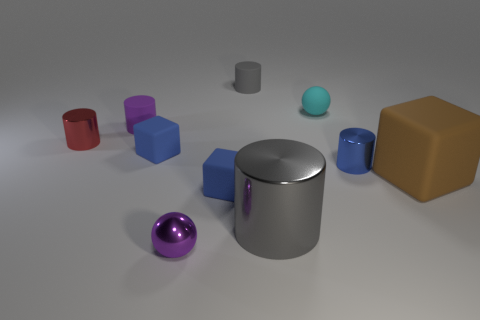Is there any other thing that has the same size as the matte sphere?
Offer a terse response. Yes. There is a gray thing that is behind the purple thing that is behind the rubber block right of the small gray matte thing; what is its shape?
Ensure brevity in your answer.  Cylinder. There is a big thing that is right of the tiny cyan ball; is its shape the same as the purple rubber object that is left of the small purple ball?
Provide a succinct answer. No. Is there a gray cylinder made of the same material as the tiny blue cylinder?
Offer a terse response. Yes. There is a small metal cylinder that is on the left side of the tiny sphere on the left side of the rubber thing that is behind the tiny cyan ball; what is its color?
Make the answer very short. Red. Are the cylinder left of the purple rubber thing and the blue cube that is in front of the big brown matte cube made of the same material?
Offer a very short reply. No. What shape is the small shiny object left of the small purple rubber object?
Keep it short and to the point. Cylinder. What number of objects are either red metallic cylinders or spheres right of the red metal object?
Provide a succinct answer. 3. Is the material of the purple cylinder the same as the blue cylinder?
Offer a very short reply. No. Are there the same number of tiny blue objects in front of the small purple shiny sphere and large brown blocks that are in front of the brown block?
Keep it short and to the point. Yes. 